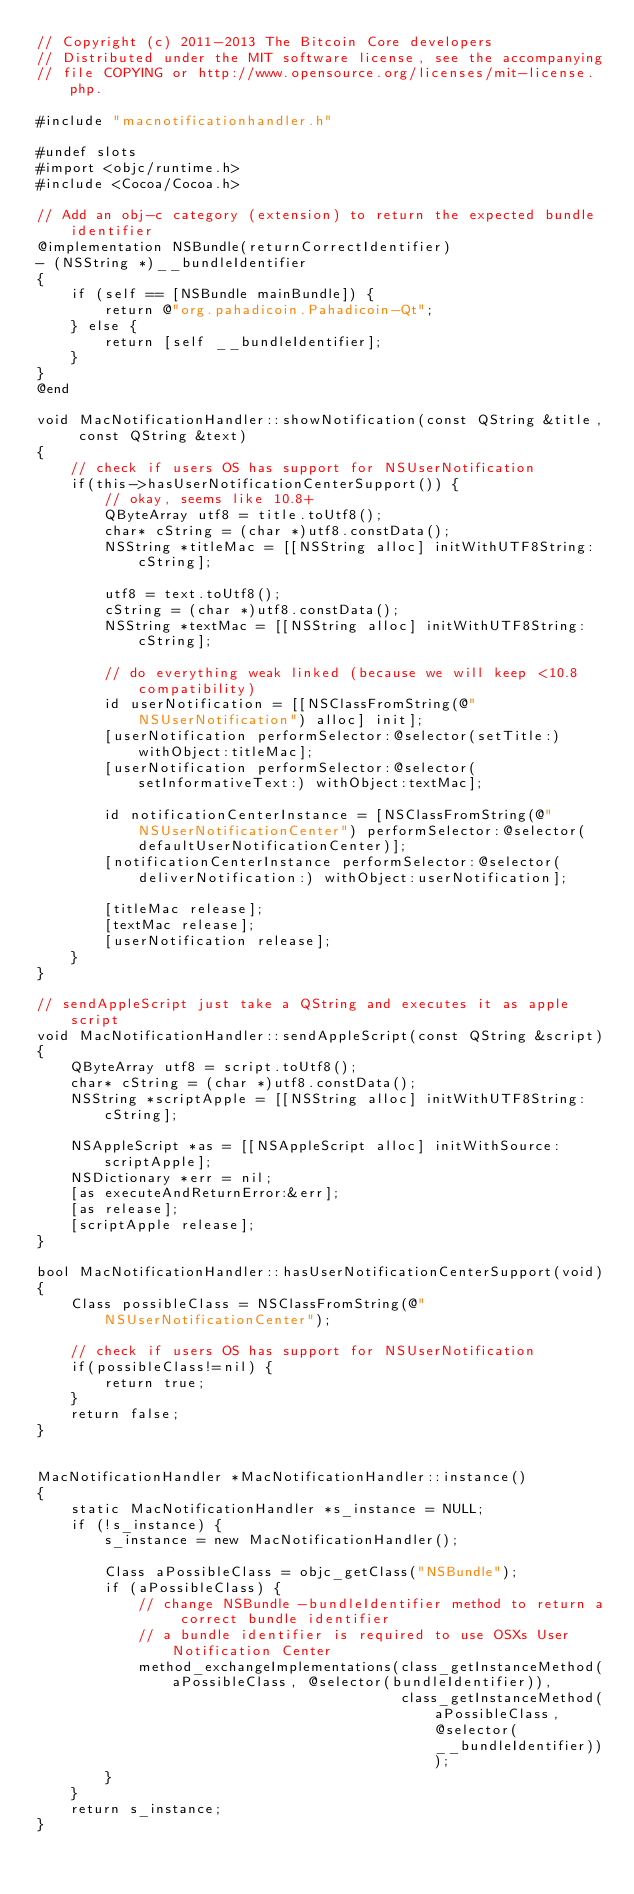Convert code to text. <code><loc_0><loc_0><loc_500><loc_500><_ObjectiveC_>// Copyright (c) 2011-2013 The Bitcoin Core developers
// Distributed under the MIT software license, see the accompanying
// file COPYING or http://www.opensource.org/licenses/mit-license.php.

#include "macnotificationhandler.h"

#undef slots
#import <objc/runtime.h>
#include <Cocoa/Cocoa.h>

// Add an obj-c category (extension) to return the expected bundle identifier
@implementation NSBundle(returnCorrectIdentifier)
- (NSString *)__bundleIdentifier
{
    if (self == [NSBundle mainBundle]) {
        return @"org.pahadicoin.Pahadicoin-Qt";
    } else {
        return [self __bundleIdentifier];
    }
}
@end

void MacNotificationHandler::showNotification(const QString &title, const QString &text)
{
    // check if users OS has support for NSUserNotification
    if(this->hasUserNotificationCenterSupport()) {
        // okay, seems like 10.8+
        QByteArray utf8 = title.toUtf8();
        char* cString = (char *)utf8.constData();
        NSString *titleMac = [[NSString alloc] initWithUTF8String:cString];

        utf8 = text.toUtf8();
        cString = (char *)utf8.constData();
        NSString *textMac = [[NSString alloc] initWithUTF8String:cString];

        // do everything weak linked (because we will keep <10.8 compatibility)
        id userNotification = [[NSClassFromString(@"NSUserNotification") alloc] init];
        [userNotification performSelector:@selector(setTitle:) withObject:titleMac];
        [userNotification performSelector:@selector(setInformativeText:) withObject:textMac];

        id notificationCenterInstance = [NSClassFromString(@"NSUserNotificationCenter") performSelector:@selector(defaultUserNotificationCenter)];
        [notificationCenterInstance performSelector:@selector(deliverNotification:) withObject:userNotification];

        [titleMac release];
        [textMac release];
        [userNotification release];
    }
}

// sendAppleScript just take a QString and executes it as apple script
void MacNotificationHandler::sendAppleScript(const QString &script)
{
    QByteArray utf8 = script.toUtf8();
    char* cString = (char *)utf8.constData();
    NSString *scriptApple = [[NSString alloc] initWithUTF8String:cString];

    NSAppleScript *as = [[NSAppleScript alloc] initWithSource:scriptApple];
    NSDictionary *err = nil;
    [as executeAndReturnError:&err];
    [as release];
    [scriptApple release];
}

bool MacNotificationHandler::hasUserNotificationCenterSupport(void)
{
    Class possibleClass = NSClassFromString(@"NSUserNotificationCenter");

    // check if users OS has support for NSUserNotification
    if(possibleClass!=nil) {
        return true;
    }
    return false;
}


MacNotificationHandler *MacNotificationHandler::instance()
{
    static MacNotificationHandler *s_instance = NULL;
    if (!s_instance) {
        s_instance = new MacNotificationHandler();
        
        Class aPossibleClass = objc_getClass("NSBundle");
        if (aPossibleClass) {
            // change NSBundle -bundleIdentifier method to return a correct bundle identifier
            // a bundle identifier is required to use OSXs User Notification Center
            method_exchangeImplementations(class_getInstanceMethod(aPossibleClass, @selector(bundleIdentifier)),
                                           class_getInstanceMethod(aPossibleClass, @selector(__bundleIdentifier)));
        }
    }
    return s_instance;
}
</code> 